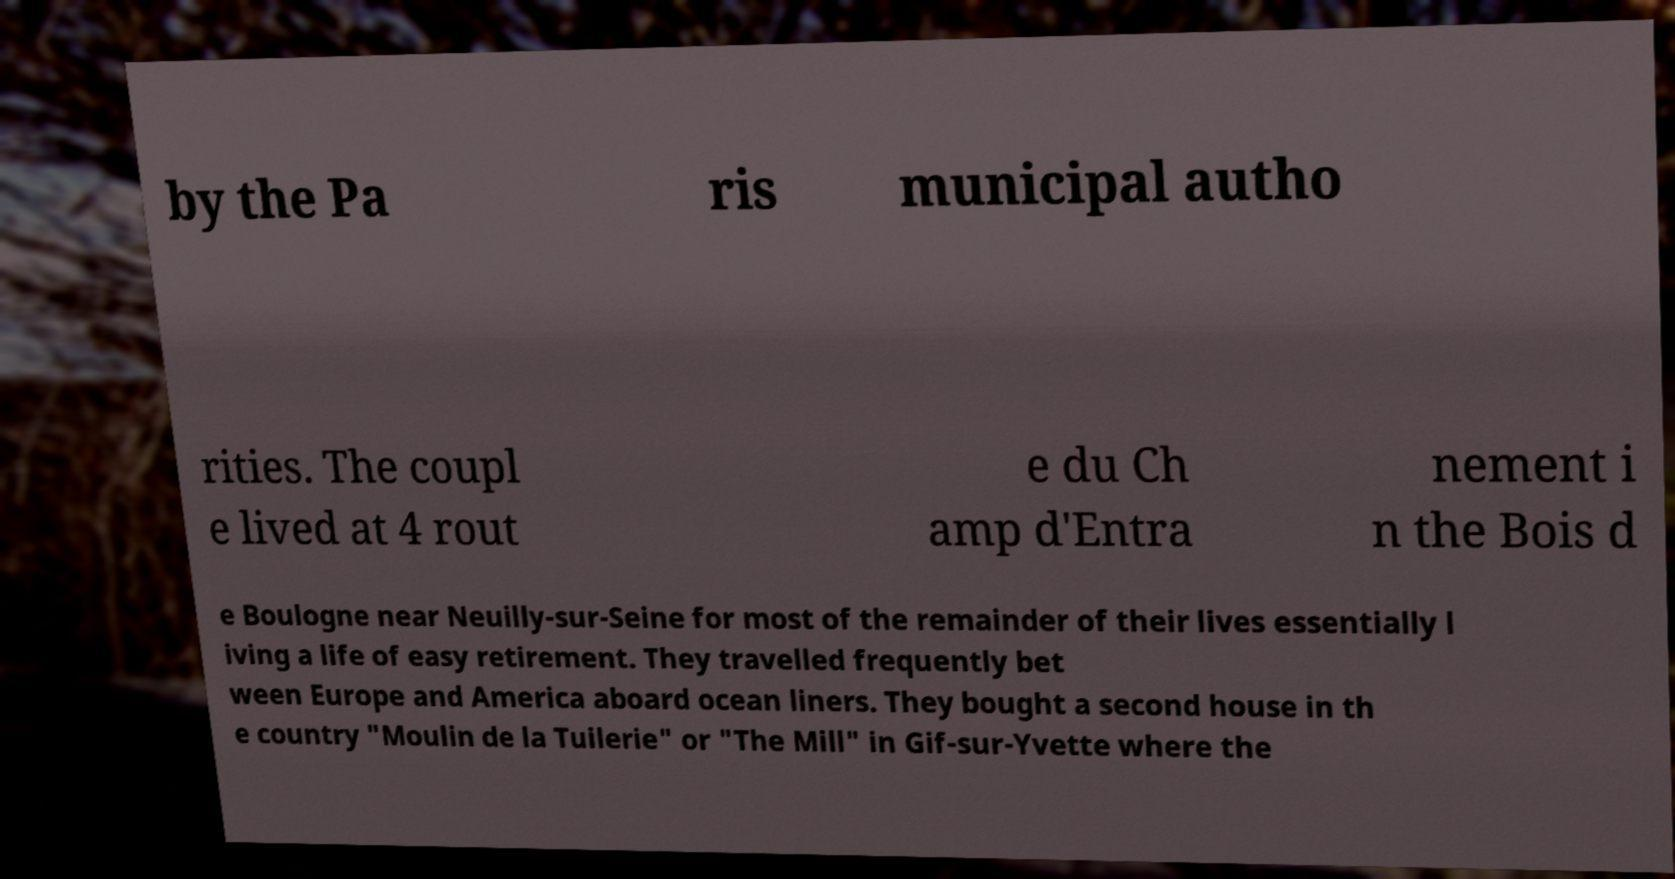For documentation purposes, I need the text within this image transcribed. Could you provide that? by the Pa ris municipal autho rities. The coupl e lived at 4 rout e du Ch amp d'Entra nement i n the Bois d e Boulogne near Neuilly-sur-Seine for most of the remainder of their lives essentially l iving a life of easy retirement. They travelled frequently bet ween Europe and America aboard ocean liners. They bought a second house in th e country "Moulin de la Tuilerie" or "The Mill" in Gif-sur-Yvette where the 